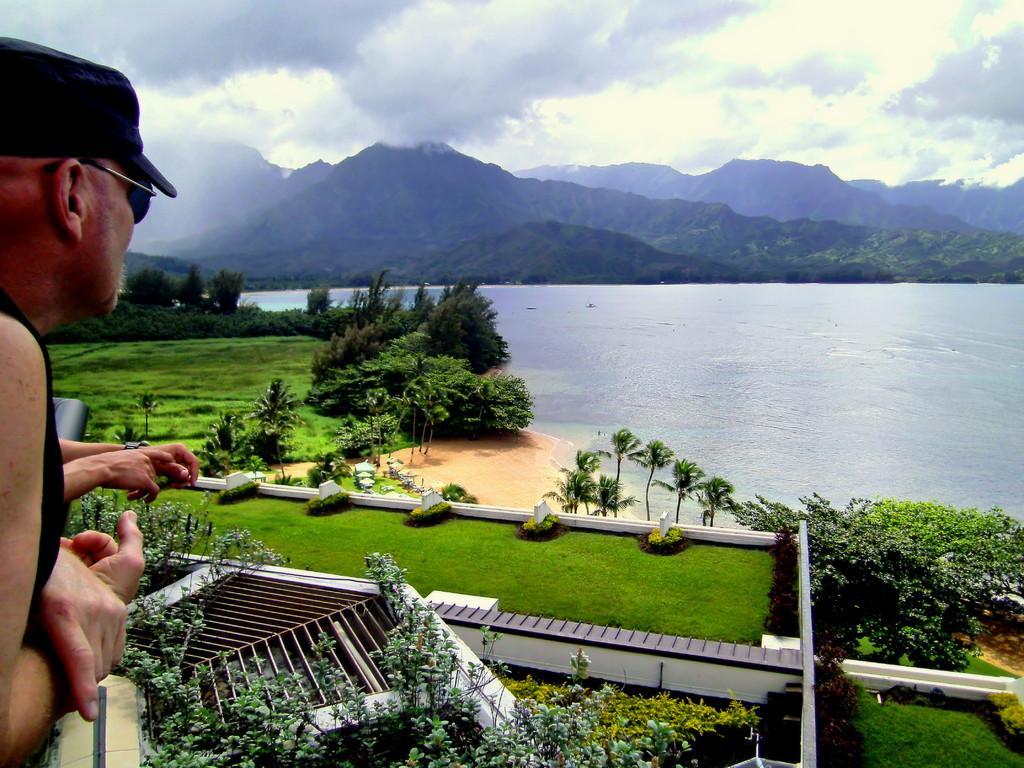Please provide a concise description of this image. In this image we can see person and person hand, there are some trees grass, sand, water, mountains and sky. 